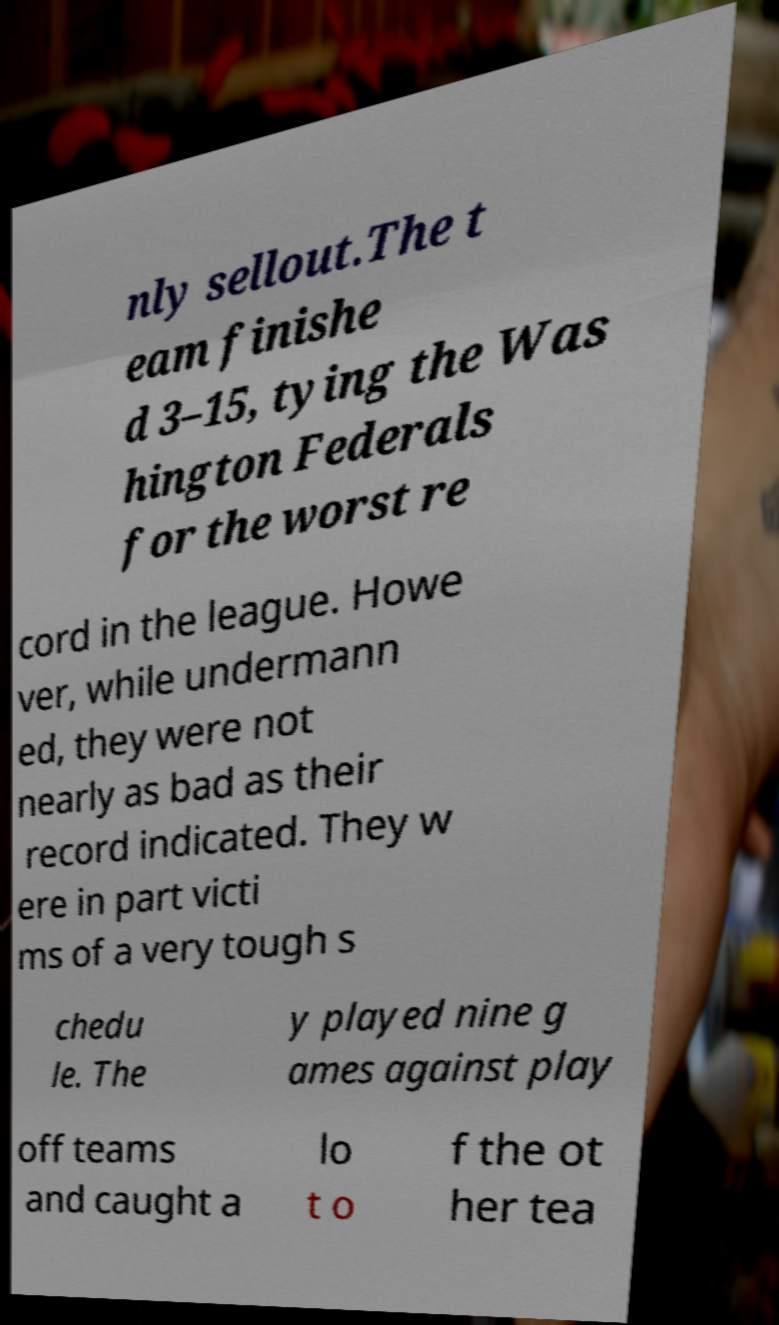I need the written content from this picture converted into text. Can you do that? nly sellout.The t eam finishe d 3–15, tying the Was hington Federals for the worst re cord in the league. Howe ver, while undermann ed, they were not nearly as bad as their record indicated. They w ere in part victi ms of a very tough s chedu le. The y played nine g ames against play off teams and caught a lo t o f the ot her tea 